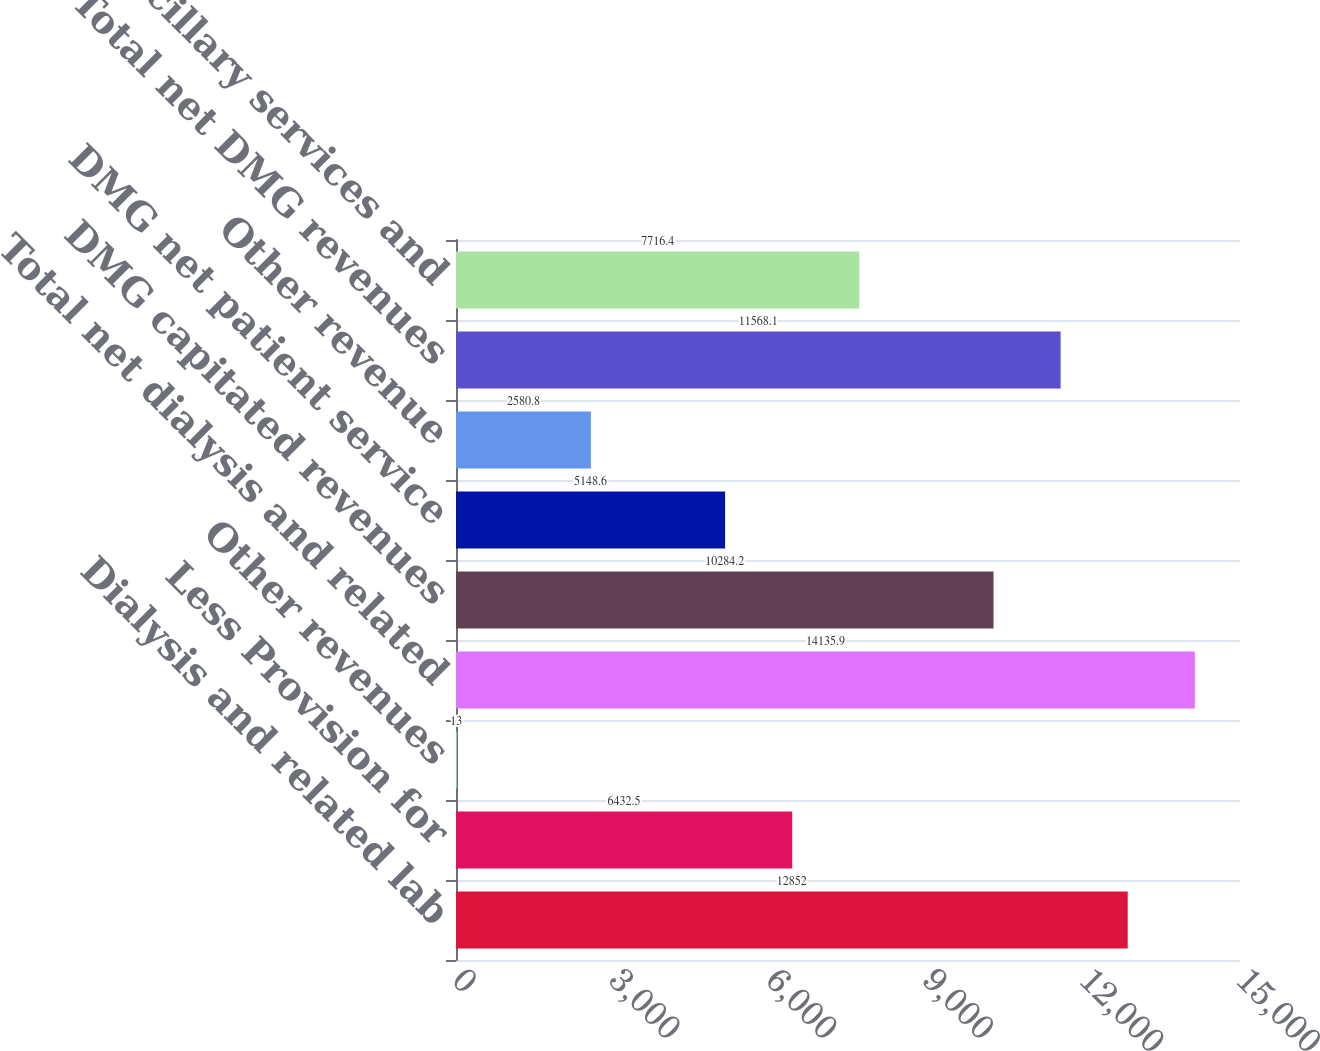Convert chart. <chart><loc_0><loc_0><loc_500><loc_500><bar_chart><fcel>Dialysis and related lab<fcel>Less Provision for<fcel>Other revenues<fcel>Total net dialysis and related<fcel>DMG capitated revenues<fcel>DMG net patient service<fcel>Other revenue<fcel>Total net DMG revenues<fcel>Other-ancillary services and<nl><fcel>12852<fcel>6432.5<fcel>13<fcel>14135.9<fcel>10284.2<fcel>5148.6<fcel>2580.8<fcel>11568.1<fcel>7716.4<nl></chart> 